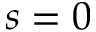Convert formula to latex. <formula><loc_0><loc_0><loc_500><loc_500>s = 0</formula> 